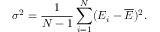Convert formula to latex. <formula><loc_0><loc_0><loc_500><loc_500>\sigma ^ { 2 } = \frac { 1 } N - 1 } \sum _ { i = 1 } ^ { N } ( E _ { i } - \overline { E } ) ^ { 2 } .</formula> 